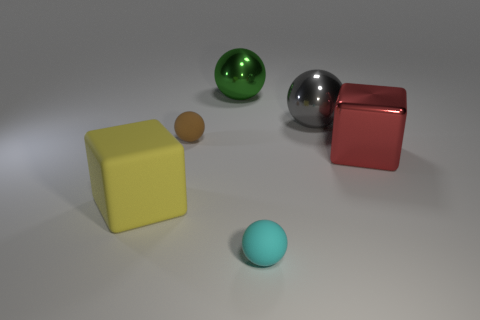How many yellow objects are large things or matte objects?
Ensure brevity in your answer.  1. What number of other things are the same material as the brown ball?
Offer a terse response. 2. There is a small rubber thing that is behind the yellow matte block; does it have the same shape as the cyan object?
Your answer should be very brief. Yes. Are any green shiny cylinders visible?
Your response must be concise. No. Are there more gray shiny spheres that are on the left side of the red thing than blue cubes?
Ensure brevity in your answer.  Yes. There is a green ball; are there any tiny brown matte objects in front of it?
Your answer should be compact. Yes. Is the brown matte sphere the same size as the cyan matte ball?
Offer a very short reply. Yes. The brown matte thing that is the same shape as the small cyan thing is what size?
Offer a very short reply. Small. Is there any other thing that is the same size as the metallic cube?
Your response must be concise. Yes. The big block that is left of the shiny sphere that is to the left of the gray ball is made of what material?
Provide a succinct answer. Rubber. 